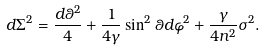<formula> <loc_0><loc_0><loc_500><loc_500>d \Sigma ^ { 2 } = \frac { d \theta ^ { 2 } } { 4 } + \frac { 1 } { 4 \gamma } \sin ^ { 2 } \theta d \varphi ^ { 2 } + \frac { \gamma } { 4 n ^ { 2 } } \sigma ^ { 2 } .</formula> 